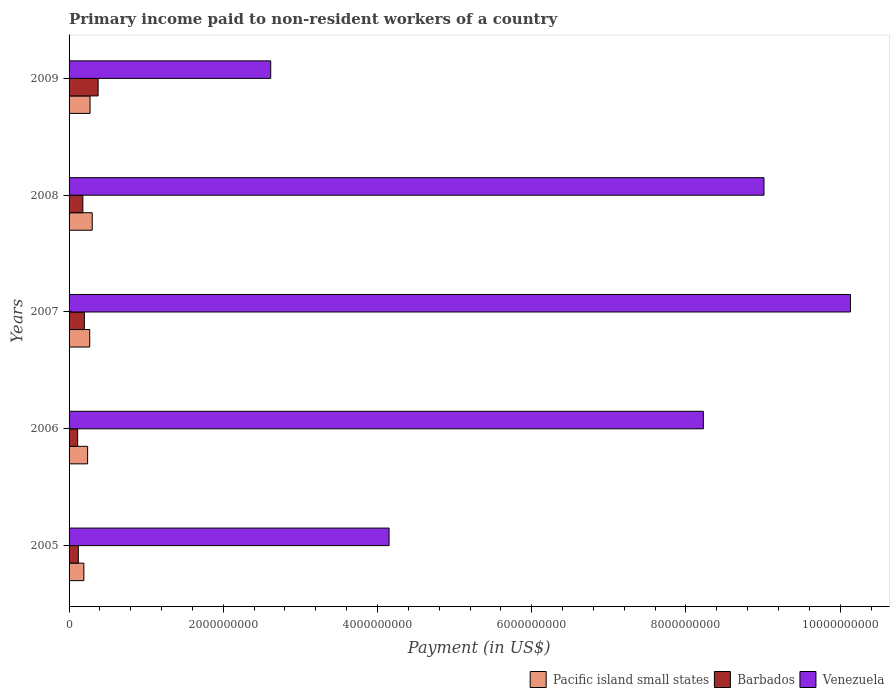Are the number of bars per tick equal to the number of legend labels?
Offer a very short reply. Yes. Are the number of bars on each tick of the Y-axis equal?
Your answer should be very brief. Yes. How many bars are there on the 5th tick from the bottom?
Your answer should be compact. 3. What is the label of the 1st group of bars from the top?
Make the answer very short. 2009. In how many cases, is the number of bars for a given year not equal to the number of legend labels?
Make the answer very short. 0. What is the amount paid to workers in Venezuela in 2009?
Make the answer very short. 2.62e+09. Across all years, what is the maximum amount paid to workers in Pacific island small states?
Offer a terse response. 3.00e+08. Across all years, what is the minimum amount paid to workers in Barbados?
Make the answer very short. 1.11e+08. In which year was the amount paid to workers in Barbados maximum?
Make the answer very short. 2009. In which year was the amount paid to workers in Pacific island small states minimum?
Provide a short and direct response. 2005. What is the total amount paid to workers in Pacific island small states in the graph?
Offer a very short reply. 1.27e+09. What is the difference between the amount paid to workers in Pacific island small states in 2006 and that in 2009?
Your answer should be compact. -3.14e+07. What is the difference between the amount paid to workers in Venezuela in 2006 and the amount paid to workers in Pacific island small states in 2007?
Offer a very short reply. 7.96e+09. What is the average amount paid to workers in Venezuela per year?
Your answer should be very brief. 6.83e+09. In the year 2008, what is the difference between the amount paid to workers in Venezuela and amount paid to workers in Pacific island small states?
Your response must be concise. 8.71e+09. What is the ratio of the amount paid to workers in Barbados in 2006 to that in 2007?
Your response must be concise. 0.56. What is the difference between the highest and the second highest amount paid to workers in Venezuela?
Offer a very short reply. 1.12e+09. What is the difference between the highest and the lowest amount paid to workers in Venezuela?
Give a very brief answer. 7.52e+09. In how many years, is the amount paid to workers in Venezuela greater than the average amount paid to workers in Venezuela taken over all years?
Provide a succinct answer. 3. Is the sum of the amount paid to workers in Pacific island small states in 2005 and 2008 greater than the maximum amount paid to workers in Venezuela across all years?
Your response must be concise. No. What does the 2nd bar from the top in 2009 represents?
Offer a very short reply. Barbados. What does the 2nd bar from the bottom in 2007 represents?
Your answer should be compact. Barbados. Is it the case that in every year, the sum of the amount paid to workers in Venezuela and amount paid to workers in Pacific island small states is greater than the amount paid to workers in Barbados?
Your response must be concise. Yes. How many bars are there?
Ensure brevity in your answer.  15. Are all the bars in the graph horizontal?
Provide a succinct answer. Yes. How many years are there in the graph?
Your answer should be compact. 5. Are the values on the major ticks of X-axis written in scientific E-notation?
Ensure brevity in your answer.  No. Does the graph contain grids?
Make the answer very short. No. Where does the legend appear in the graph?
Offer a terse response. Bottom right. How many legend labels are there?
Your answer should be compact. 3. How are the legend labels stacked?
Your answer should be compact. Horizontal. What is the title of the graph?
Ensure brevity in your answer.  Primary income paid to non-resident workers of a country. Does "Somalia" appear as one of the legend labels in the graph?
Your answer should be compact. No. What is the label or title of the X-axis?
Make the answer very short. Payment (in US$). What is the label or title of the Y-axis?
Provide a short and direct response. Years. What is the Payment (in US$) in Pacific island small states in 2005?
Provide a succinct answer. 1.92e+08. What is the Payment (in US$) of Barbados in 2005?
Offer a terse response. 1.20e+08. What is the Payment (in US$) in Venezuela in 2005?
Provide a short and direct response. 4.15e+09. What is the Payment (in US$) in Pacific island small states in 2006?
Keep it short and to the point. 2.41e+08. What is the Payment (in US$) in Barbados in 2006?
Offer a very short reply. 1.11e+08. What is the Payment (in US$) in Venezuela in 2006?
Offer a very short reply. 8.23e+09. What is the Payment (in US$) in Pacific island small states in 2007?
Your answer should be compact. 2.68e+08. What is the Payment (in US$) in Barbados in 2007?
Your answer should be compact. 1.98e+08. What is the Payment (in US$) in Venezuela in 2007?
Offer a very short reply. 1.01e+1. What is the Payment (in US$) of Pacific island small states in 2008?
Your response must be concise. 3.00e+08. What is the Payment (in US$) of Barbados in 2008?
Keep it short and to the point. 1.79e+08. What is the Payment (in US$) of Venezuela in 2008?
Offer a terse response. 9.01e+09. What is the Payment (in US$) of Pacific island small states in 2009?
Offer a terse response. 2.72e+08. What is the Payment (in US$) in Barbados in 2009?
Your answer should be very brief. 3.77e+08. What is the Payment (in US$) in Venezuela in 2009?
Give a very brief answer. 2.62e+09. Across all years, what is the maximum Payment (in US$) of Pacific island small states?
Offer a terse response. 3.00e+08. Across all years, what is the maximum Payment (in US$) in Barbados?
Ensure brevity in your answer.  3.77e+08. Across all years, what is the maximum Payment (in US$) in Venezuela?
Give a very brief answer. 1.01e+1. Across all years, what is the minimum Payment (in US$) of Pacific island small states?
Offer a terse response. 1.92e+08. Across all years, what is the minimum Payment (in US$) in Barbados?
Provide a succinct answer. 1.11e+08. Across all years, what is the minimum Payment (in US$) of Venezuela?
Ensure brevity in your answer.  2.62e+09. What is the total Payment (in US$) in Pacific island small states in the graph?
Ensure brevity in your answer.  1.27e+09. What is the total Payment (in US$) in Barbados in the graph?
Ensure brevity in your answer.  9.85e+08. What is the total Payment (in US$) in Venezuela in the graph?
Give a very brief answer. 3.41e+1. What is the difference between the Payment (in US$) in Pacific island small states in 2005 and that in 2006?
Your answer should be compact. -4.89e+07. What is the difference between the Payment (in US$) of Barbados in 2005 and that in 2006?
Your answer should be compact. 8.82e+06. What is the difference between the Payment (in US$) of Venezuela in 2005 and that in 2006?
Give a very brief answer. -4.08e+09. What is the difference between the Payment (in US$) in Pacific island small states in 2005 and that in 2007?
Offer a terse response. -7.60e+07. What is the difference between the Payment (in US$) in Barbados in 2005 and that in 2007?
Your answer should be very brief. -7.84e+07. What is the difference between the Payment (in US$) of Venezuela in 2005 and that in 2007?
Offer a terse response. -5.98e+09. What is the difference between the Payment (in US$) in Pacific island small states in 2005 and that in 2008?
Provide a succinct answer. -1.09e+08. What is the difference between the Payment (in US$) in Barbados in 2005 and that in 2008?
Provide a short and direct response. -5.87e+07. What is the difference between the Payment (in US$) of Venezuela in 2005 and that in 2008?
Provide a succinct answer. -4.86e+09. What is the difference between the Payment (in US$) in Pacific island small states in 2005 and that in 2009?
Make the answer very short. -8.04e+07. What is the difference between the Payment (in US$) of Barbados in 2005 and that in 2009?
Keep it short and to the point. -2.57e+08. What is the difference between the Payment (in US$) of Venezuela in 2005 and that in 2009?
Offer a very short reply. 1.54e+09. What is the difference between the Payment (in US$) in Pacific island small states in 2006 and that in 2007?
Offer a terse response. -2.71e+07. What is the difference between the Payment (in US$) in Barbados in 2006 and that in 2007?
Keep it short and to the point. -8.72e+07. What is the difference between the Payment (in US$) of Venezuela in 2006 and that in 2007?
Your answer should be compact. -1.91e+09. What is the difference between the Payment (in US$) of Pacific island small states in 2006 and that in 2008?
Offer a terse response. -5.96e+07. What is the difference between the Payment (in US$) of Barbados in 2006 and that in 2008?
Provide a succinct answer. -6.75e+07. What is the difference between the Payment (in US$) in Venezuela in 2006 and that in 2008?
Make the answer very short. -7.86e+08. What is the difference between the Payment (in US$) of Pacific island small states in 2006 and that in 2009?
Give a very brief answer. -3.14e+07. What is the difference between the Payment (in US$) of Barbados in 2006 and that in 2009?
Your answer should be compact. -2.66e+08. What is the difference between the Payment (in US$) in Venezuela in 2006 and that in 2009?
Your answer should be very brief. 5.61e+09. What is the difference between the Payment (in US$) in Pacific island small states in 2007 and that in 2008?
Make the answer very short. -3.25e+07. What is the difference between the Payment (in US$) in Barbados in 2007 and that in 2008?
Offer a very short reply. 1.97e+07. What is the difference between the Payment (in US$) of Venezuela in 2007 and that in 2008?
Provide a short and direct response. 1.12e+09. What is the difference between the Payment (in US$) in Pacific island small states in 2007 and that in 2009?
Provide a succinct answer. -4.37e+06. What is the difference between the Payment (in US$) of Barbados in 2007 and that in 2009?
Make the answer very short. -1.78e+08. What is the difference between the Payment (in US$) in Venezuela in 2007 and that in 2009?
Give a very brief answer. 7.52e+09. What is the difference between the Payment (in US$) in Pacific island small states in 2008 and that in 2009?
Offer a very short reply. 2.82e+07. What is the difference between the Payment (in US$) in Barbados in 2008 and that in 2009?
Your response must be concise. -1.98e+08. What is the difference between the Payment (in US$) of Venezuela in 2008 and that in 2009?
Your answer should be compact. 6.40e+09. What is the difference between the Payment (in US$) of Pacific island small states in 2005 and the Payment (in US$) of Barbados in 2006?
Offer a terse response. 8.06e+07. What is the difference between the Payment (in US$) in Pacific island small states in 2005 and the Payment (in US$) in Venezuela in 2006?
Offer a terse response. -8.03e+09. What is the difference between the Payment (in US$) in Barbados in 2005 and the Payment (in US$) in Venezuela in 2006?
Offer a very short reply. -8.11e+09. What is the difference between the Payment (in US$) of Pacific island small states in 2005 and the Payment (in US$) of Barbados in 2007?
Provide a succinct answer. -6.53e+06. What is the difference between the Payment (in US$) of Pacific island small states in 2005 and the Payment (in US$) of Venezuela in 2007?
Provide a succinct answer. -9.94e+09. What is the difference between the Payment (in US$) in Barbados in 2005 and the Payment (in US$) in Venezuela in 2007?
Make the answer very short. -1.00e+1. What is the difference between the Payment (in US$) in Pacific island small states in 2005 and the Payment (in US$) in Barbados in 2008?
Ensure brevity in your answer.  1.32e+07. What is the difference between the Payment (in US$) in Pacific island small states in 2005 and the Payment (in US$) in Venezuela in 2008?
Make the answer very short. -8.82e+09. What is the difference between the Payment (in US$) in Barbados in 2005 and the Payment (in US$) in Venezuela in 2008?
Provide a succinct answer. -8.89e+09. What is the difference between the Payment (in US$) of Pacific island small states in 2005 and the Payment (in US$) of Barbados in 2009?
Your response must be concise. -1.85e+08. What is the difference between the Payment (in US$) in Pacific island small states in 2005 and the Payment (in US$) in Venezuela in 2009?
Ensure brevity in your answer.  -2.42e+09. What is the difference between the Payment (in US$) in Barbados in 2005 and the Payment (in US$) in Venezuela in 2009?
Your response must be concise. -2.50e+09. What is the difference between the Payment (in US$) in Pacific island small states in 2006 and the Payment (in US$) in Barbados in 2007?
Offer a terse response. 4.24e+07. What is the difference between the Payment (in US$) in Pacific island small states in 2006 and the Payment (in US$) in Venezuela in 2007?
Make the answer very short. -9.89e+09. What is the difference between the Payment (in US$) in Barbados in 2006 and the Payment (in US$) in Venezuela in 2007?
Ensure brevity in your answer.  -1.00e+1. What is the difference between the Payment (in US$) of Pacific island small states in 2006 and the Payment (in US$) of Barbados in 2008?
Offer a very short reply. 6.21e+07. What is the difference between the Payment (in US$) of Pacific island small states in 2006 and the Payment (in US$) of Venezuela in 2008?
Your answer should be very brief. -8.77e+09. What is the difference between the Payment (in US$) in Barbados in 2006 and the Payment (in US$) in Venezuela in 2008?
Ensure brevity in your answer.  -8.90e+09. What is the difference between the Payment (in US$) of Pacific island small states in 2006 and the Payment (in US$) of Barbados in 2009?
Give a very brief answer. -1.36e+08. What is the difference between the Payment (in US$) of Pacific island small states in 2006 and the Payment (in US$) of Venezuela in 2009?
Provide a short and direct response. -2.37e+09. What is the difference between the Payment (in US$) in Barbados in 2006 and the Payment (in US$) in Venezuela in 2009?
Your answer should be compact. -2.50e+09. What is the difference between the Payment (in US$) of Pacific island small states in 2007 and the Payment (in US$) of Barbados in 2008?
Provide a short and direct response. 8.92e+07. What is the difference between the Payment (in US$) in Pacific island small states in 2007 and the Payment (in US$) in Venezuela in 2008?
Your response must be concise. -8.74e+09. What is the difference between the Payment (in US$) in Barbados in 2007 and the Payment (in US$) in Venezuela in 2008?
Provide a short and direct response. -8.81e+09. What is the difference between the Payment (in US$) of Pacific island small states in 2007 and the Payment (in US$) of Barbados in 2009?
Your answer should be compact. -1.09e+08. What is the difference between the Payment (in US$) in Pacific island small states in 2007 and the Payment (in US$) in Venezuela in 2009?
Give a very brief answer. -2.35e+09. What is the difference between the Payment (in US$) of Barbados in 2007 and the Payment (in US$) of Venezuela in 2009?
Offer a terse response. -2.42e+09. What is the difference between the Payment (in US$) in Pacific island small states in 2008 and the Payment (in US$) in Barbados in 2009?
Offer a very short reply. -7.65e+07. What is the difference between the Payment (in US$) in Pacific island small states in 2008 and the Payment (in US$) in Venezuela in 2009?
Provide a succinct answer. -2.31e+09. What is the difference between the Payment (in US$) of Barbados in 2008 and the Payment (in US$) of Venezuela in 2009?
Your response must be concise. -2.44e+09. What is the average Payment (in US$) in Pacific island small states per year?
Give a very brief answer. 2.54e+08. What is the average Payment (in US$) of Barbados per year?
Your answer should be very brief. 1.97e+08. What is the average Payment (in US$) of Venezuela per year?
Your response must be concise. 6.83e+09. In the year 2005, what is the difference between the Payment (in US$) in Pacific island small states and Payment (in US$) in Barbados?
Offer a very short reply. 7.18e+07. In the year 2005, what is the difference between the Payment (in US$) of Pacific island small states and Payment (in US$) of Venezuela?
Your answer should be very brief. -3.96e+09. In the year 2005, what is the difference between the Payment (in US$) in Barbados and Payment (in US$) in Venezuela?
Offer a very short reply. -4.03e+09. In the year 2006, what is the difference between the Payment (in US$) in Pacific island small states and Payment (in US$) in Barbados?
Keep it short and to the point. 1.30e+08. In the year 2006, what is the difference between the Payment (in US$) in Pacific island small states and Payment (in US$) in Venezuela?
Your answer should be compact. -7.99e+09. In the year 2006, what is the difference between the Payment (in US$) of Barbados and Payment (in US$) of Venezuela?
Offer a very short reply. -8.11e+09. In the year 2007, what is the difference between the Payment (in US$) of Pacific island small states and Payment (in US$) of Barbados?
Make the answer very short. 6.95e+07. In the year 2007, what is the difference between the Payment (in US$) in Pacific island small states and Payment (in US$) in Venezuela?
Give a very brief answer. -9.87e+09. In the year 2007, what is the difference between the Payment (in US$) of Barbados and Payment (in US$) of Venezuela?
Provide a short and direct response. -9.93e+09. In the year 2008, what is the difference between the Payment (in US$) in Pacific island small states and Payment (in US$) in Barbados?
Offer a terse response. 1.22e+08. In the year 2008, what is the difference between the Payment (in US$) of Pacific island small states and Payment (in US$) of Venezuela?
Provide a short and direct response. -8.71e+09. In the year 2008, what is the difference between the Payment (in US$) in Barbados and Payment (in US$) in Venezuela?
Keep it short and to the point. -8.83e+09. In the year 2009, what is the difference between the Payment (in US$) of Pacific island small states and Payment (in US$) of Barbados?
Give a very brief answer. -1.05e+08. In the year 2009, what is the difference between the Payment (in US$) of Pacific island small states and Payment (in US$) of Venezuela?
Offer a very short reply. -2.34e+09. In the year 2009, what is the difference between the Payment (in US$) of Barbados and Payment (in US$) of Venezuela?
Offer a terse response. -2.24e+09. What is the ratio of the Payment (in US$) in Pacific island small states in 2005 to that in 2006?
Ensure brevity in your answer.  0.8. What is the ratio of the Payment (in US$) in Barbados in 2005 to that in 2006?
Your response must be concise. 1.08. What is the ratio of the Payment (in US$) of Venezuela in 2005 to that in 2006?
Make the answer very short. 0.5. What is the ratio of the Payment (in US$) of Pacific island small states in 2005 to that in 2007?
Your response must be concise. 0.72. What is the ratio of the Payment (in US$) of Barbados in 2005 to that in 2007?
Your answer should be compact. 0.6. What is the ratio of the Payment (in US$) in Venezuela in 2005 to that in 2007?
Your answer should be very brief. 0.41. What is the ratio of the Payment (in US$) in Pacific island small states in 2005 to that in 2008?
Provide a short and direct response. 0.64. What is the ratio of the Payment (in US$) in Barbados in 2005 to that in 2008?
Offer a very short reply. 0.67. What is the ratio of the Payment (in US$) of Venezuela in 2005 to that in 2008?
Your answer should be very brief. 0.46. What is the ratio of the Payment (in US$) of Pacific island small states in 2005 to that in 2009?
Provide a short and direct response. 0.7. What is the ratio of the Payment (in US$) in Barbados in 2005 to that in 2009?
Offer a terse response. 0.32. What is the ratio of the Payment (in US$) in Venezuela in 2005 to that in 2009?
Keep it short and to the point. 1.59. What is the ratio of the Payment (in US$) of Pacific island small states in 2006 to that in 2007?
Ensure brevity in your answer.  0.9. What is the ratio of the Payment (in US$) of Barbados in 2006 to that in 2007?
Ensure brevity in your answer.  0.56. What is the ratio of the Payment (in US$) in Venezuela in 2006 to that in 2007?
Your response must be concise. 0.81. What is the ratio of the Payment (in US$) in Pacific island small states in 2006 to that in 2008?
Your answer should be compact. 0.8. What is the ratio of the Payment (in US$) in Barbados in 2006 to that in 2008?
Offer a very short reply. 0.62. What is the ratio of the Payment (in US$) in Venezuela in 2006 to that in 2008?
Your response must be concise. 0.91. What is the ratio of the Payment (in US$) in Pacific island small states in 2006 to that in 2009?
Make the answer very short. 0.88. What is the ratio of the Payment (in US$) in Barbados in 2006 to that in 2009?
Make the answer very short. 0.29. What is the ratio of the Payment (in US$) in Venezuela in 2006 to that in 2009?
Provide a short and direct response. 3.15. What is the ratio of the Payment (in US$) of Pacific island small states in 2007 to that in 2008?
Give a very brief answer. 0.89. What is the ratio of the Payment (in US$) in Barbados in 2007 to that in 2008?
Make the answer very short. 1.11. What is the ratio of the Payment (in US$) in Venezuela in 2007 to that in 2008?
Make the answer very short. 1.12. What is the ratio of the Payment (in US$) of Pacific island small states in 2007 to that in 2009?
Provide a short and direct response. 0.98. What is the ratio of the Payment (in US$) of Barbados in 2007 to that in 2009?
Your answer should be compact. 0.53. What is the ratio of the Payment (in US$) in Venezuela in 2007 to that in 2009?
Your response must be concise. 3.88. What is the ratio of the Payment (in US$) in Pacific island small states in 2008 to that in 2009?
Your response must be concise. 1.1. What is the ratio of the Payment (in US$) of Barbados in 2008 to that in 2009?
Offer a very short reply. 0.47. What is the ratio of the Payment (in US$) of Venezuela in 2008 to that in 2009?
Provide a short and direct response. 3.45. What is the difference between the highest and the second highest Payment (in US$) in Pacific island small states?
Provide a short and direct response. 2.82e+07. What is the difference between the highest and the second highest Payment (in US$) of Barbados?
Keep it short and to the point. 1.78e+08. What is the difference between the highest and the second highest Payment (in US$) of Venezuela?
Ensure brevity in your answer.  1.12e+09. What is the difference between the highest and the lowest Payment (in US$) in Pacific island small states?
Your answer should be compact. 1.09e+08. What is the difference between the highest and the lowest Payment (in US$) in Barbados?
Your answer should be compact. 2.66e+08. What is the difference between the highest and the lowest Payment (in US$) in Venezuela?
Provide a succinct answer. 7.52e+09. 